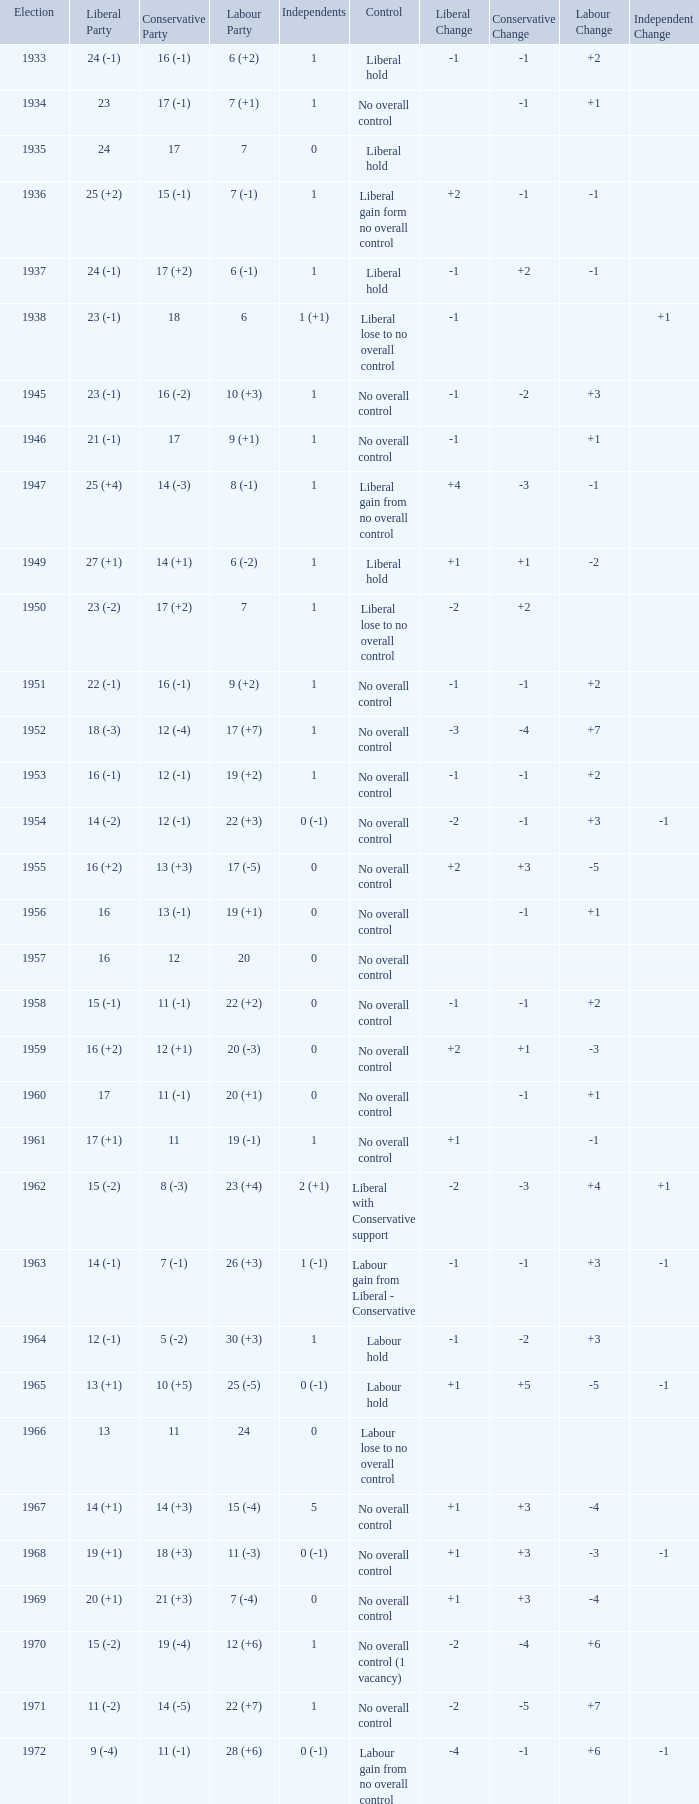What is the number of Independents elected in the year Labour won 26 (+3) seats? 1 (-1). 